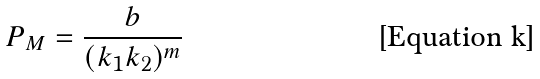<formula> <loc_0><loc_0><loc_500><loc_500>P _ { M } = \frac { b } { ( k _ { 1 } k _ { 2 } ) ^ { m } }</formula> 